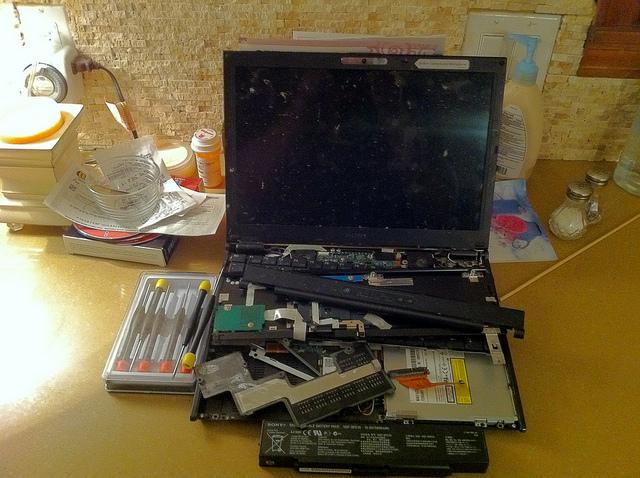Do you think this laptop is beyond repair?
Answer briefly. Yes. Are the medicine bottle (left) and the salt and pepper shakers (right) part of the laptop?
Concise answer only. No. Is the computer screen on?
Answer briefly. No. 